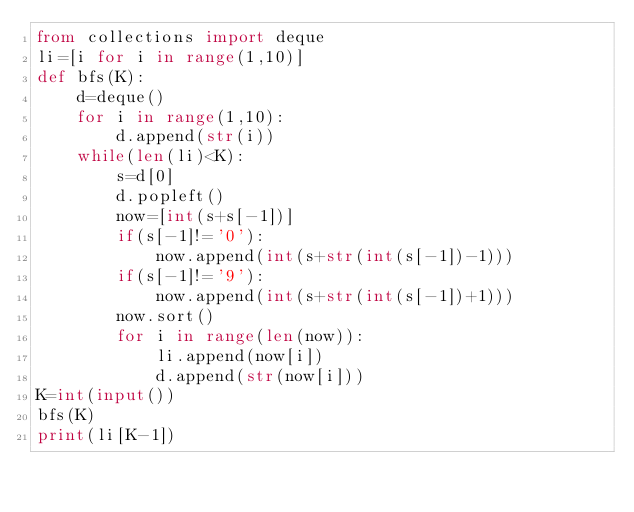<code> <loc_0><loc_0><loc_500><loc_500><_Python_>from collections import deque
li=[i for i in range(1,10)]
def bfs(K):
    d=deque()
    for i in range(1,10):
        d.append(str(i))
    while(len(li)<K):
        s=d[0]
        d.popleft()
        now=[int(s+s[-1])]
        if(s[-1]!='0'):
            now.append(int(s+str(int(s[-1])-1)))
        if(s[-1]!='9'):
            now.append(int(s+str(int(s[-1])+1)))
        now.sort()
        for i in range(len(now)):
            li.append(now[i])
            d.append(str(now[i]))
K=int(input())
bfs(K)
print(li[K-1])</code> 